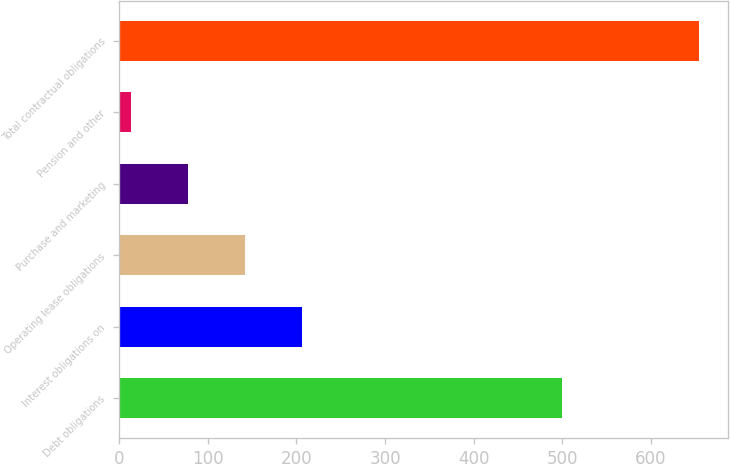Convert chart to OTSL. <chart><loc_0><loc_0><loc_500><loc_500><bar_chart><fcel>Debt obligations<fcel>Interest obligations on<fcel>Operating lease obligations<fcel>Purchase and marketing<fcel>Pension and other<fcel>Total contractual obligations<nl><fcel>500<fcel>205.8<fcel>141.7<fcel>77.6<fcel>13.5<fcel>654.5<nl></chart> 